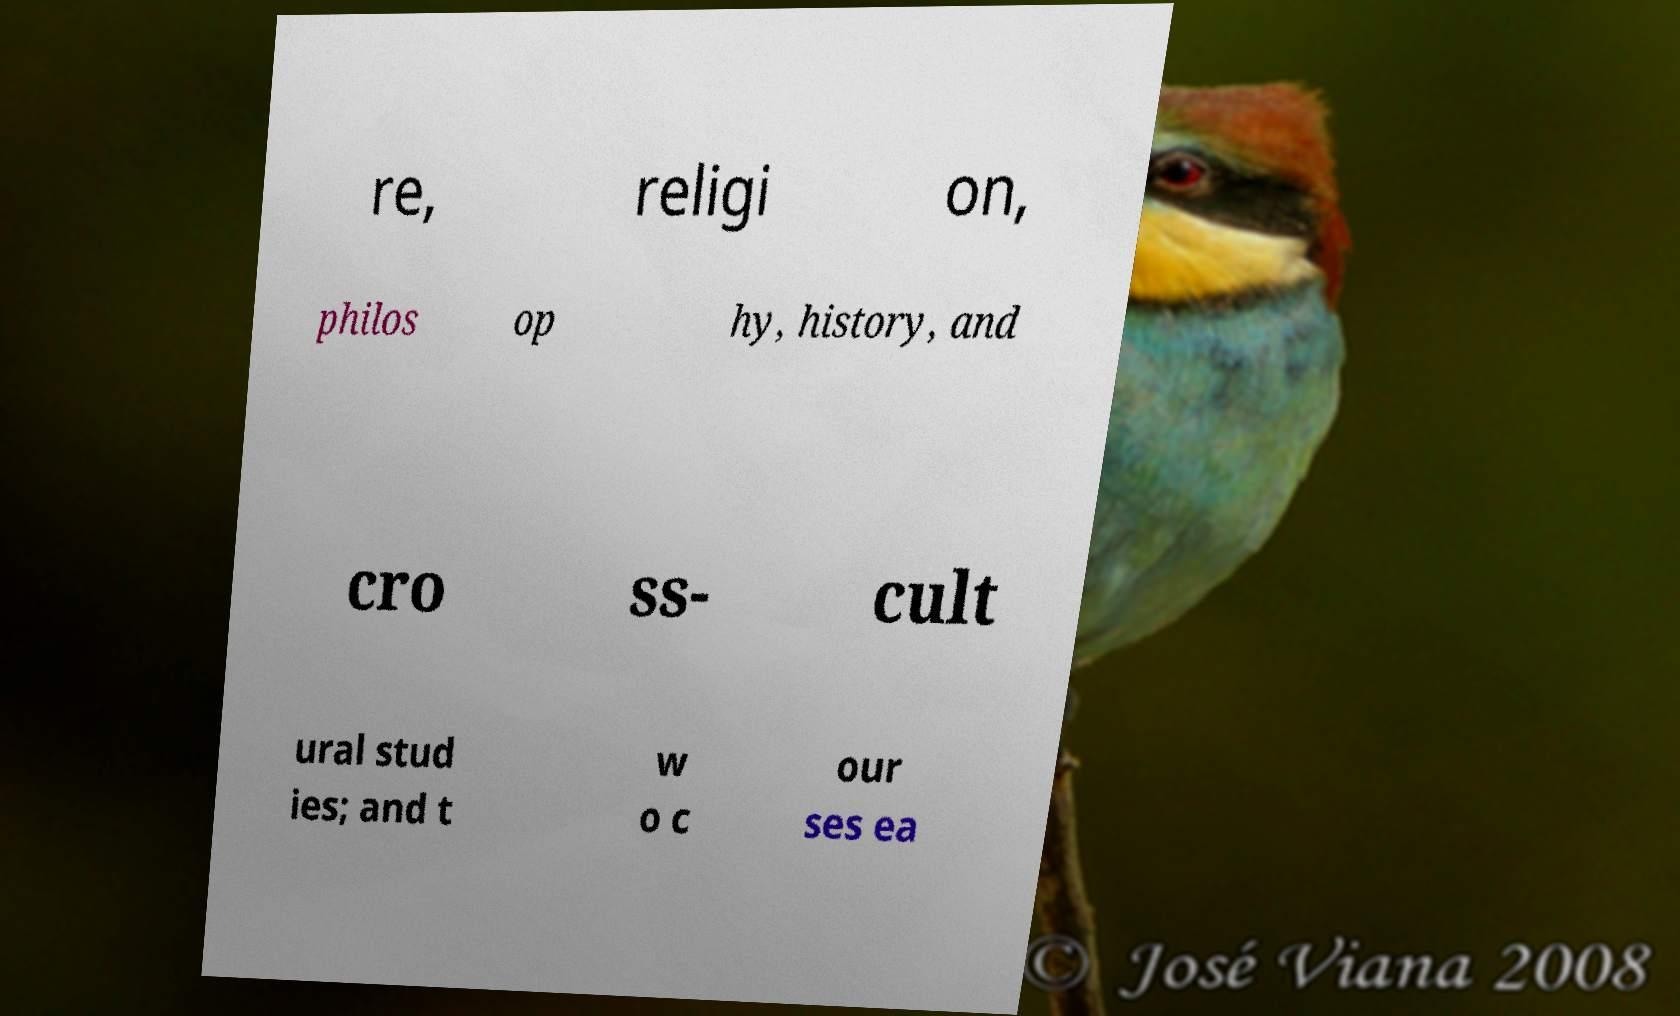Can you read and provide the text displayed in the image?This photo seems to have some interesting text. Can you extract and type it out for me? re, religi on, philos op hy, history, and cro ss- cult ural stud ies; and t w o c our ses ea 